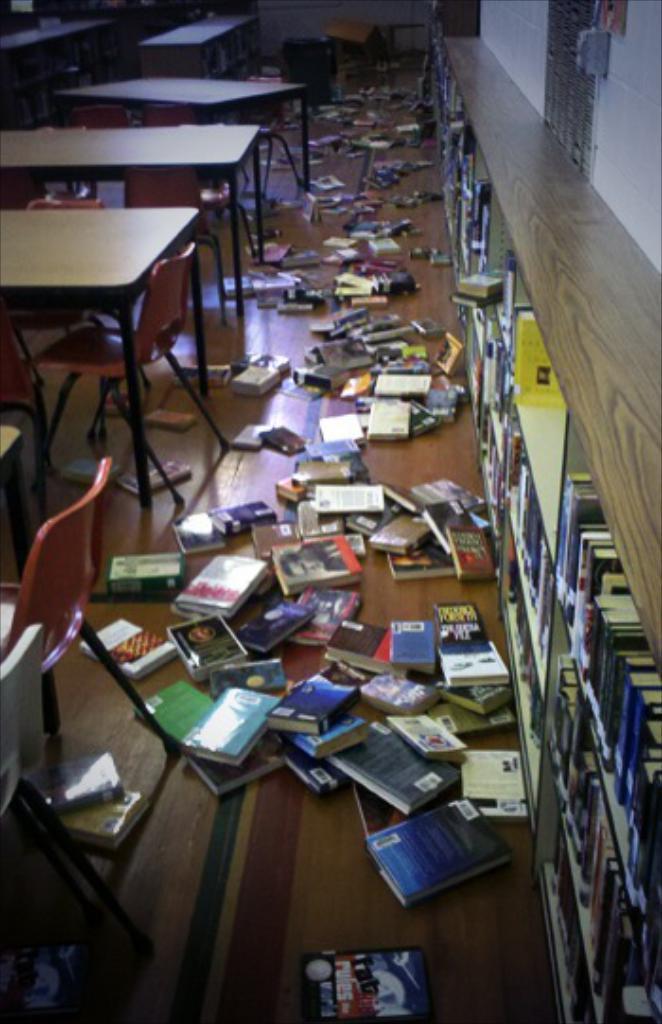In one or two sentences, can you explain what this image depicts? In this image we can see tables, chairs, books, and other objects on the floor. On the right side of the image we can see books on the racks, wall, and other objects. 